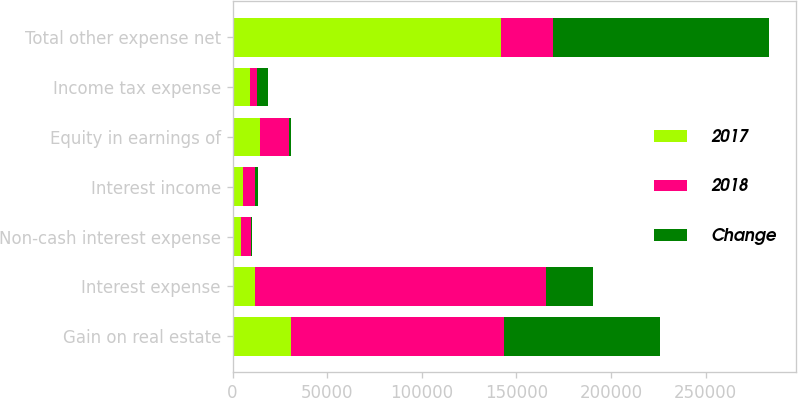<chart> <loc_0><loc_0><loc_500><loc_500><stacked_bar_chart><ecel><fcel>Gain on real estate<fcel>Interest expense<fcel>Non-cash interest expense<fcel>Interest income<fcel>Equity in earnings of<fcel>Income tax expense<fcel>Total other expense net<nl><fcel>2017<fcel>30807<fcel>11848<fcel>4687<fcel>5292<fcel>14452<fcel>9244<fcel>141816<nl><fcel>2018<fcel>112789<fcel>153511<fcel>5103<fcel>6736<fcel>15331<fcel>3625<fcel>27383<nl><fcel>Change<fcel>81982<fcel>24925<fcel>416<fcel>1444<fcel>879<fcel>5619<fcel>114433<nl></chart> 